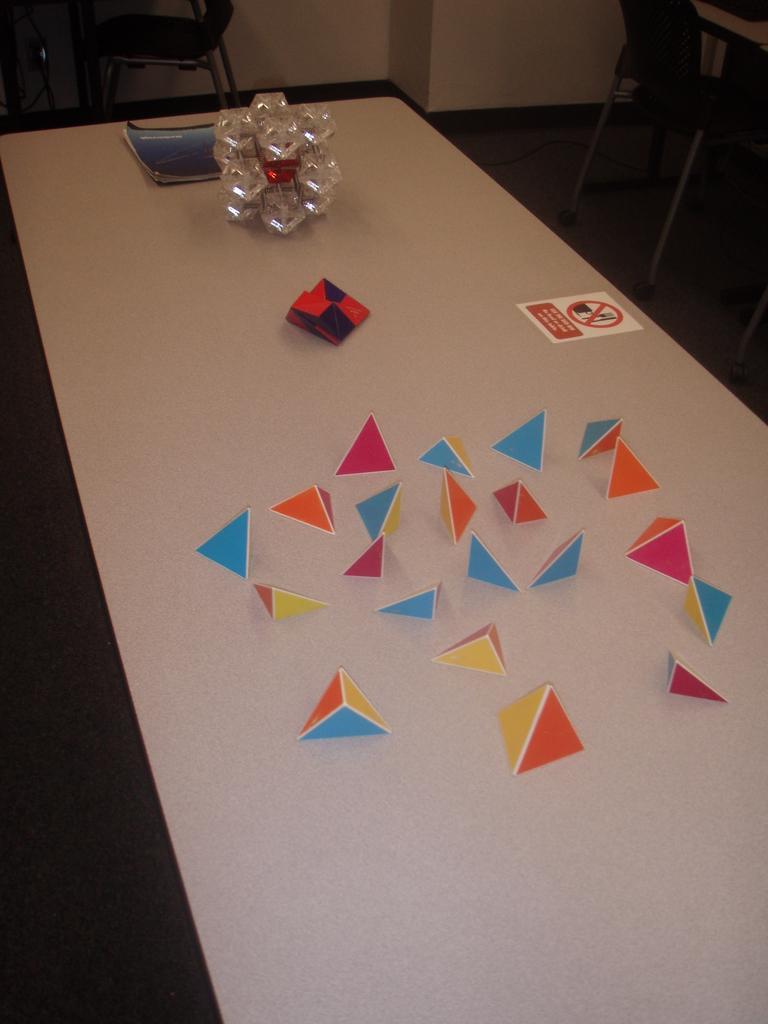Describe this image in one or two sentences. In the image we can see a table, white in color. On the table we can see there are few objects and a book. Here we can see the chairs, floor and the wall 